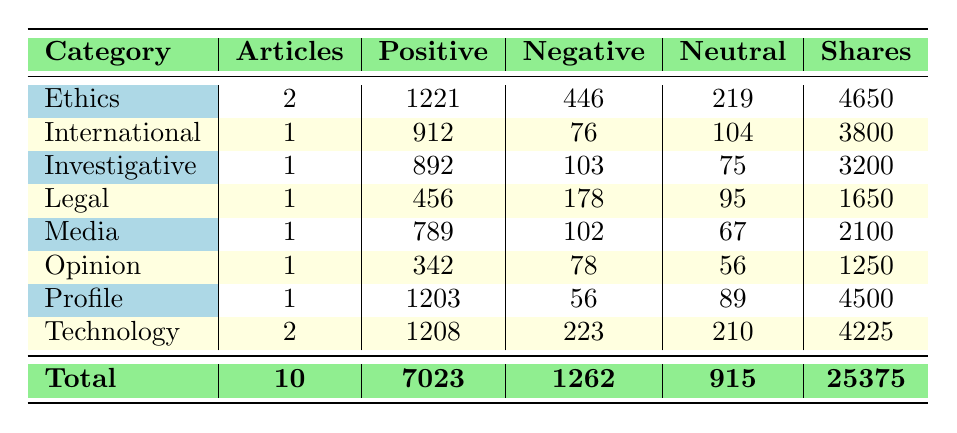What is the total number of articles in the analysis? The table specifies a total of 10 articles. This is found in the "Total" row under the "Articles" column.
Answer: 10 Which category received the highest positive feedback? To find this, I look at the "Positive" column for all categories. Ethics has 1221 positive feedback, which is the highest compared to other categories.
Answer: Ethics What is the sum of neutral feedback across all categories? I add the neutral feedback figures from each category: 219 + 104 + 75 + 95 + 67 + 56 + 89 + 210 = 915. Therefore, the total neutral feedback is 915.
Answer: 915 Did any article in the Legal category receive more negative feedback than the Opinion category? The Legal category has 178 negative feedback while the Opinion category has 78. Since 178 is greater than 78, the statement is true.
Answer: Yes What is the average number of shares among all articles? To find the average number of shares, I sum the shares across all categories: 4650 + 3800 + 3200 + 1650 + 2100 + 1250 + 4500 + 4225 = 25375. Then I divide by the number of articles, which is 10. Thus, the average shares are 25375 / 10 = 2537.5.
Answer: 2537.5 Which category, besides Profile and Ethics, had the least number of shares? Looking at the "Shares" column, I notice that both Opinion and Legal categories have shares of 1250 and 1650, respectively. The Opinion category has the least among these two, with 1250 shares.
Answer: Opinion What is the difference in positive feedback between the Technology and Investigative categories? The Technology category has 1208 positive feedback, while Investigative has 892. Subtracting these gives: 1208 - 892 = 316. The difference is 316 positive feedback.
Answer: 316 How many categories reported negative feedback less than 100? I filter the "Negative" column and check each category: International (76), Profile (56), and none others below 100. Therefore, there are three categories with negative feedback less than 100.
Answer: 3 Which article category had a combined total of 1208 positive feedback? Scanning the "Positive" column, I see that the Technology category has 1208 positive feedback, which is the combined total for that category.
Answer: Technology 